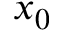<formula> <loc_0><loc_0><loc_500><loc_500>x _ { 0 }</formula> 